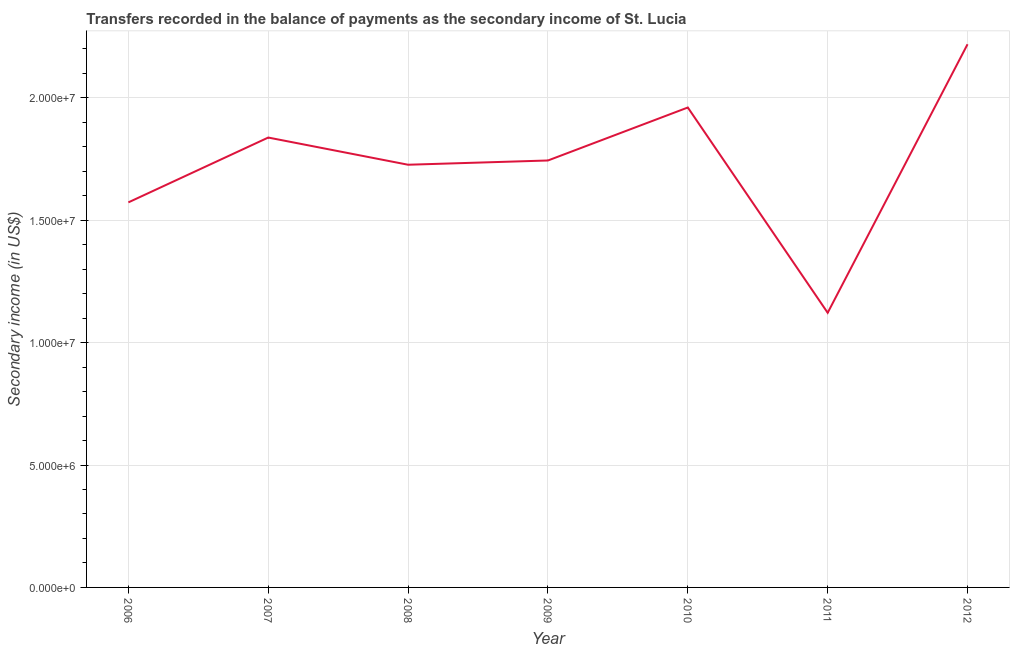What is the amount of secondary income in 2010?
Keep it short and to the point. 1.96e+07. Across all years, what is the maximum amount of secondary income?
Provide a short and direct response. 2.22e+07. Across all years, what is the minimum amount of secondary income?
Keep it short and to the point. 1.12e+07. In which year was the amount of secondary income maximum?
Keep it short and to the point. 2012. What is the sum of the amount of secondary income?
Your answer should be very brief. 1.22e+08. What is the difference between the amount of secondary income in 2007 and 2010?
Offer a very short reply. -1.23e+06. What is the average amount of secondary income per year?
Provide a short and direct response. 1.74e+07. What is the median amount of secondary income?
Your answer should be very brief. 1.74e+07. In how many years, is the amount of secondary income greater than 3000000 US$?
Provide a succinct answer. 7. Do a majority of the years between 2009 and 2006 (inclusive) have amount of secondary income greater than 4000000 US$?
Keep it short and to the point. Yes. What is the ratio of the amount of secondary income in 2006 to that in 2008?
Keep it short and to the point. 0.91. Is the difference between the amount of secondary income in 2009 and 2010 greater than the difference between any two years?
Provide a succinct answer. No. What is the difference between the highest and the second highest amount of secondary income?
Offer a terse response. 2.58e+06. What is the difference between the highest and the lowest amount of secondary income?
Give a very brief answer. 1.10e+07. In how many years, is the amount of secondary income greater than the average amount of secondary income taken over all years?
Your response must be concise. 4. Are the values on the major ticks of Y-axis written in scientific E-notation?
Provide a succinct answer. Yes. Does the graph contain any zero values?
Offer a very short reply. No. Does the graph contain grids?
Make the answer very short. Yes. What is the title of the graph?
Make the answer very short. Transfers recorded in the balance of payments as the secondary income of St. Lucia. What is the label or title of the Y-axis?
Offer a very short reply. Secondary income (in US$). What is the Secondary income (in US$) in 2006?
Your response must be concise. 1.57e+07. What is the Secondary income (in US$) in 2007?
Provide a succinct answer. 1.84e+07. What is the Secondary income (in US$) of 2008?
Ensure brevity in your answer.  1.73e+07. What is the Secondary income (in US$) in 2009?
Ensure brevity in your answer.  1.74e+07. What is the Secondary income (in US$) in 2010?
Ensure brevity in your answer.  1.96e+07. What is the Secondary income (in US$) in 2011?
Offer a terse response. 1.12e+07. What is the Secondary income (in US$) in 2012?
Offer a terse response. 2.22e+07. What is the difference between the Secondary income (in US$) in 2006 and 2007?
Your answer should be very brief. -2.65e+06. What is the difference between the Secondary income (in US$) in 2006 and 2008?
Offer a very short reply. -1.54e+06. What is the difference between the Secondary income (in US$) in 2006 and 2009?
Ensure brevity in your answer.  -1.71e+06. What is the difference between the Secondary income (in US$) in 2006 and 2010?
Give a very brief answer. -3.87e+06. What is the difference between the Secondary income (in US$) in 2006 and 2011?
Your response must be concise. 4.51e+06. What is the difference between the Secondary income (in US$) in 2006 and 2012?
Your response must be concise. -6.46e+06. What is the difference between the Secondary income (in US$) in 2007 and 2008?
Provide a succinct answer. 1.11e+06. What is the difference between the Secondary income (in US$) in 2007 and 2009?
Provide a succinct answer. 9.37e+05. What is the difference between the Secondary income (in US$) in 2007 and 2010?
Your response must be concise. -1.23e+06. What is the difference between the Secondary income (in US$) in 2007 and 2011?
Give a very brief answer. 7.16e+06. What is the difference between the Secondary income (in US$) in 2007 and 2012?
Your answer should be compact. -3.81e+06. What is the difference between the Secondary income (in US$) in 2008 and 2009?
Give a very brief answer. -1.74e+05. What is the difference between the Secondary income (in US$) in 2008 and 2010?
Provide a succinct answer. -2.34e+06. What is the difference between the Secondary income (in US$) in 2008 and 2011?
Your response must be concise. 6.05e+06. What is the difference between the Secondary income (in US$) in 2008 and 2012?
Your response must be concise. -4.92e+06. What is the difference between the Secondary income (in US$) in 2009 and 2010?
Keep it short and to the point. -2.16e+06. What is the difference between the Secondary income (in US$) in 2009 and 2011?
Give a very brief answer. 6.22e+06. What is the difference between the Secondary income (in US$) in 2009 and 2012?
Your response must be concise. -4.75e+06. What is the difference between the Secondary income (in US$) in 2010 and 2011?
Make the answer very short. 8.38e+06. What is the difference between the Secondary income (in US$) in 2010 and 2012?
Make the answer very short. -2.58e+06. What is the difference between the Secondary income (in US$) in 2011 and 2012?
Keep it short and to the point. -1.10e+07. What is the ratio of the Secondary income (in US$) in 2006 to that in 2007?
Offer a very short reply. 0.86. What is the ratio of the Secondary income (in US$) in 2006 to that in 2008?
Offer a terse response. 0.91. What is the ratio of the Secondary income (in US$) in 2006 to that in 2009?
Your answer should be compact. 0.9. What is the ratio of the Secondary income (in US$) in 2006 to that in 2010?
Your answer should be compact. 0.8. What is the ratio of the Secondary income (in US$) in 2006 to that in 2011?
Give a very brief answer. 1.4. What is the ratio of the Secondary income (in US$) in 2006 to that in 2012?
Keep it short and to the point. 0.71. What is the ratio of the Secondary income (in US$) in 2007 to that in 2008?
Ensure brevity in your answer.  1.06. What is the ratio of the Secondary income (in US$) in 2007 to that in 2009?
Keep it short and to the point. 1.05. What is the ratio of the Secondary income (in US$) in 2007 to that in 2010?
Keep it short and to the point. 0.94. What is the ratio of the Secondary income (in US$) in 2007 to that in 2011?
Offer a very short reply. 1.64. What is the ratio of the Secondary income (in US$) in 2007 to that in 2012?
Your answer should be compact. 0.83. What is the ratio of the Secondary income (in US$) in 2008 to that in 2009?
Give a very brief answer. 0.99. What is the ratio of the Secondary income (in US$) in 2008 to that in 2010?
Keep it short and to the point. 0.88. What is the ratio of the Secondary income (in US$) in 2008 to that in 2011?
Offer a terse response. 1.54. What is the ratio of the Secondary income (in US$) in 2008 to that in 2012?
Your answer should be very brief. 0.78. What is the ratio of the Secondary income (in US$) in 2009 to that in 2010?
Offer a very short reply. 0.89. What is the ratio of the Secondary income (in US$) in 2009 to that in 2011?
Your answer should be very brief. 1.55. What is the ratio of the Secondary income (in US$) in 2009 to that in 2012?
Ensure brevity in your answer.  0.79. What is the ratio of the Secondary income (in US$) in 2010 to that in 2011?
Offer a terse response. 1.75. What is the ratio of the Secondary income (in US$) in 2010 to that in 2012?
Your answer should be very brief. 0.88. What is the ratio of the Secondary income (in US$) in 2011 to that in 2012?
Offer a very short reply. 0.51. 